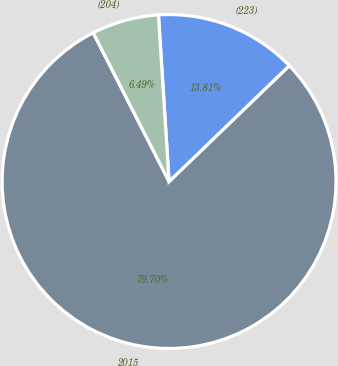<chart> <loc_0><loc_0><loc_500><loc_500><pie_chart><fcel>2015<fcel>(223)<fcel>(204)<nl><fcel>79.7%<fcel>13.81%<fcel>6.49%<nl></chart> 